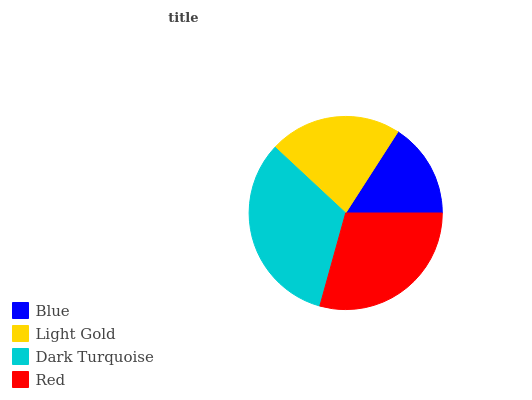Is Blue the minimum?
Answer yes or no. Yes. Is Dark Turquoise the maximum?
Answer yes or no. Yes. Is Light Gold the minimum?
Answer yes or no. No. Is Light Gold the maximum?
Answer yes or no. No. Is Light Gold greater than Blue?
Answer yes or no. Yes. Is Blue less than Light Gold?
Answer yes or no. Yes. Is Blue greater than Light Gold?
Answer yes or no. No. Is Light Gold less than Blue?
Answer yes or no. No. Is Red the high median?
Answer yes or no. Yes. Is Light Gold the low median?
Answer yes or no. Yes. Is Light Gold the high median?
Answer yes or no. No. Is Dark Turquoise the low median?
Answer yes or no. No. 